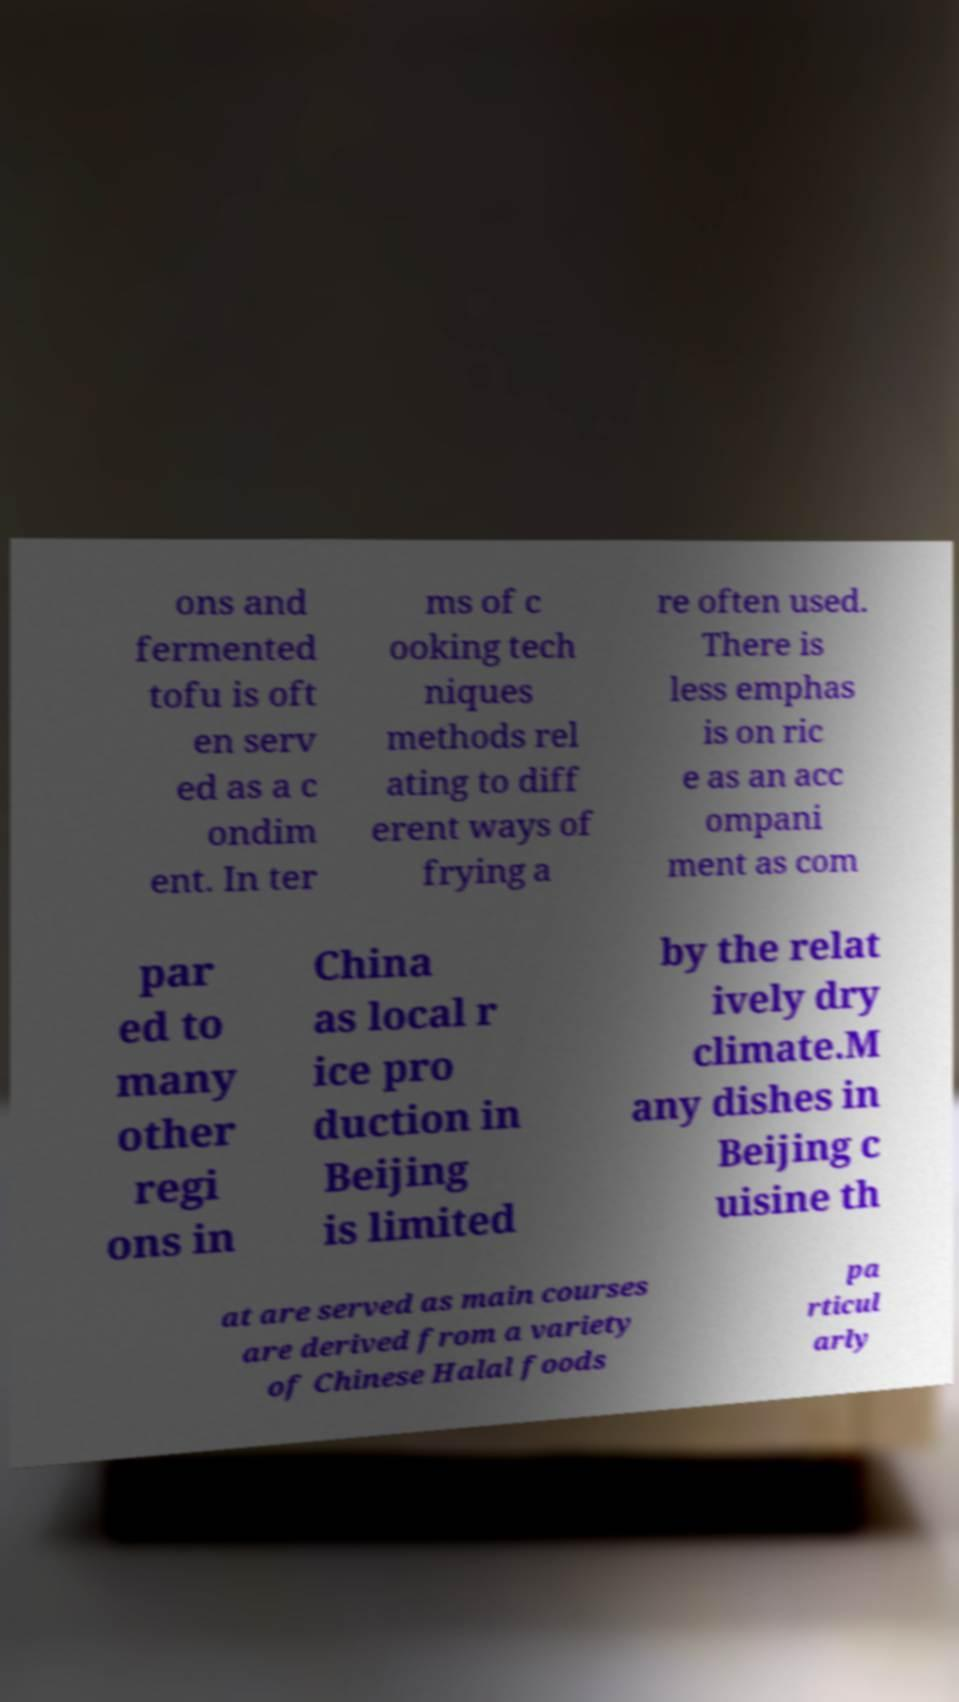What messages or text are displayed in this image? I need them in a readable, typed format. ons and fermented tofu is oft en serv ed as a c ondim ent. In ter ms of c ooking tech niques methods rel ating to diff erent ways of frying a re often used. There is less emphas is on ric e as an acc ompani ment as com par ed to many other regi ons in China as local r ice pro duction in Beijing is limited by the relat ively dry climate.M any dishes in Beijing c uisine th at are served as main courses are derived from a variety of Chinese Halal foods pa rticul arly 